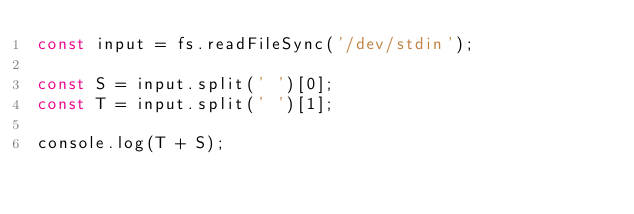<code> <loc_0><loc_0><loc_500><loc_500><_TypeScript_>const input = fs.readFileSync('/dev/stdin');

const S = input.split(' ')[0];
const T = input.split(' ')[1];

console.log(T + S);</code> 